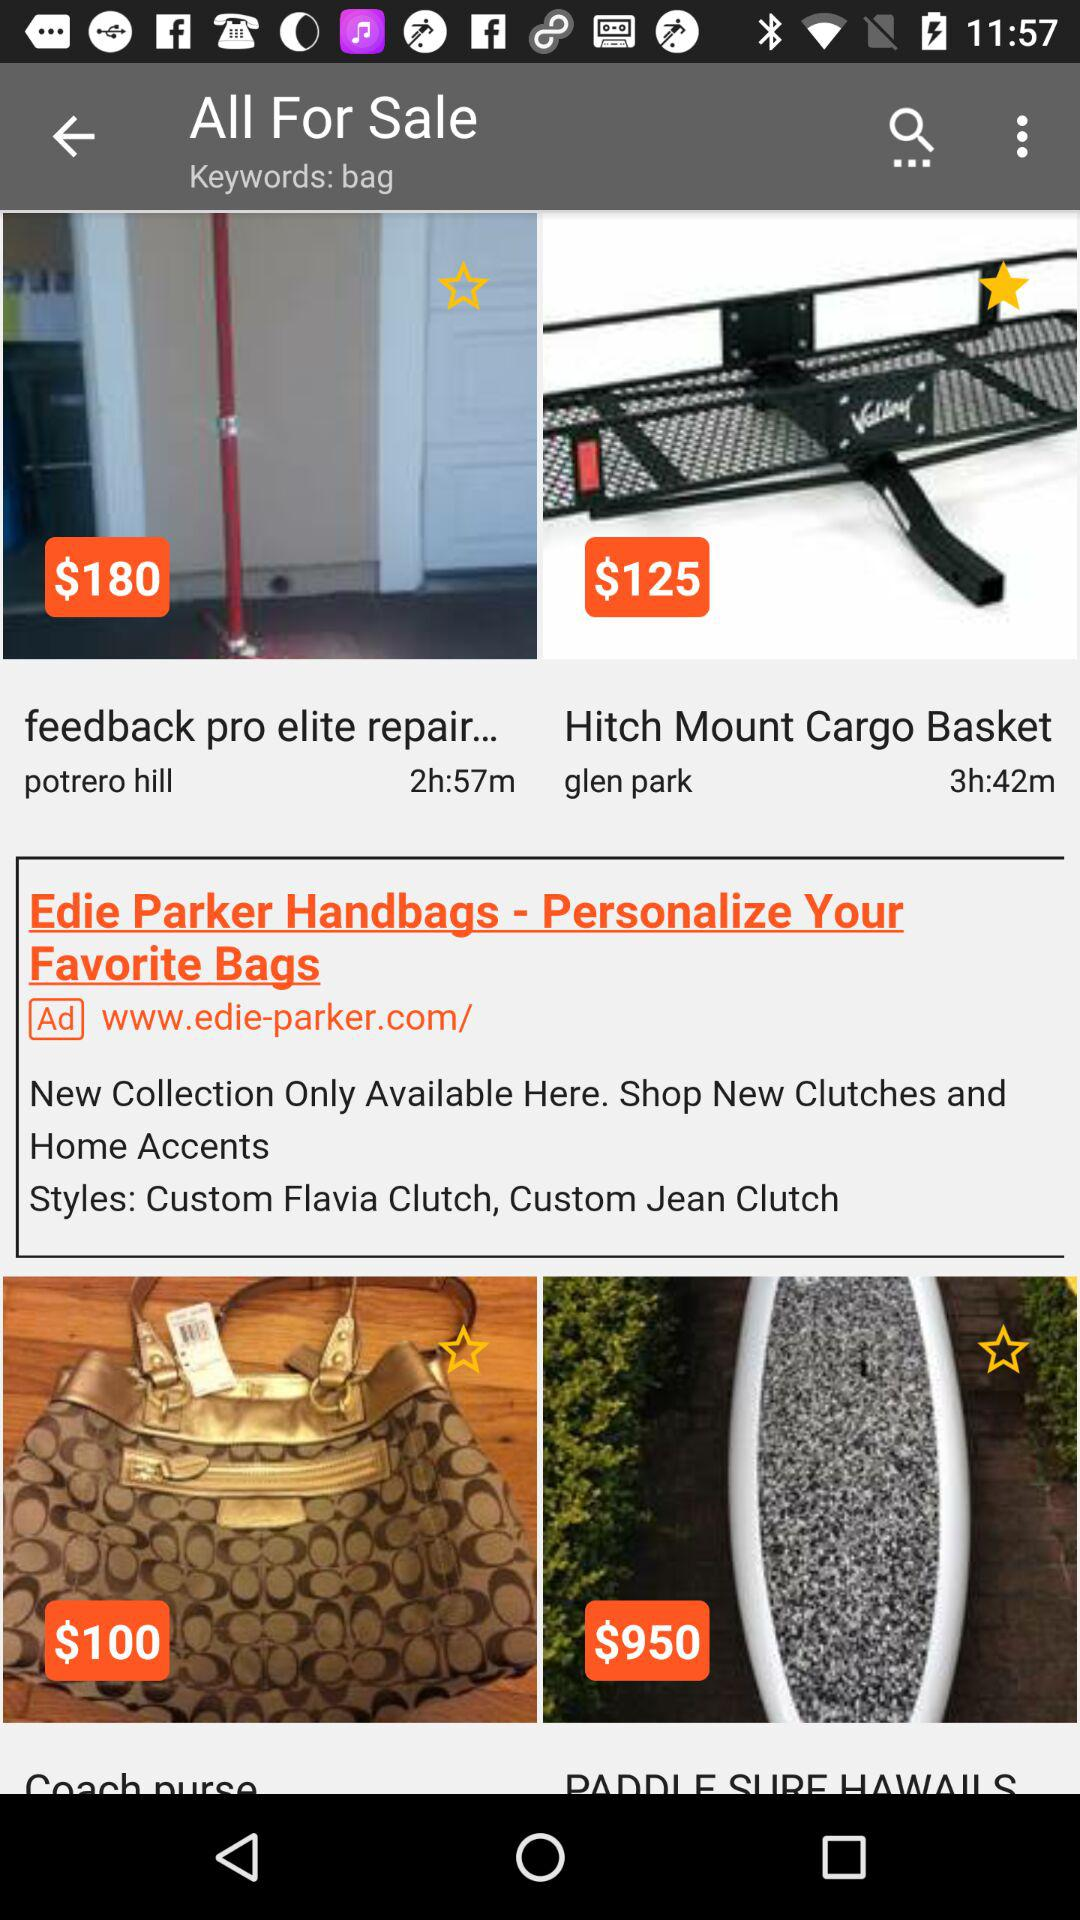What is the price of a hitch-mount cargo basket? The price is $125. 